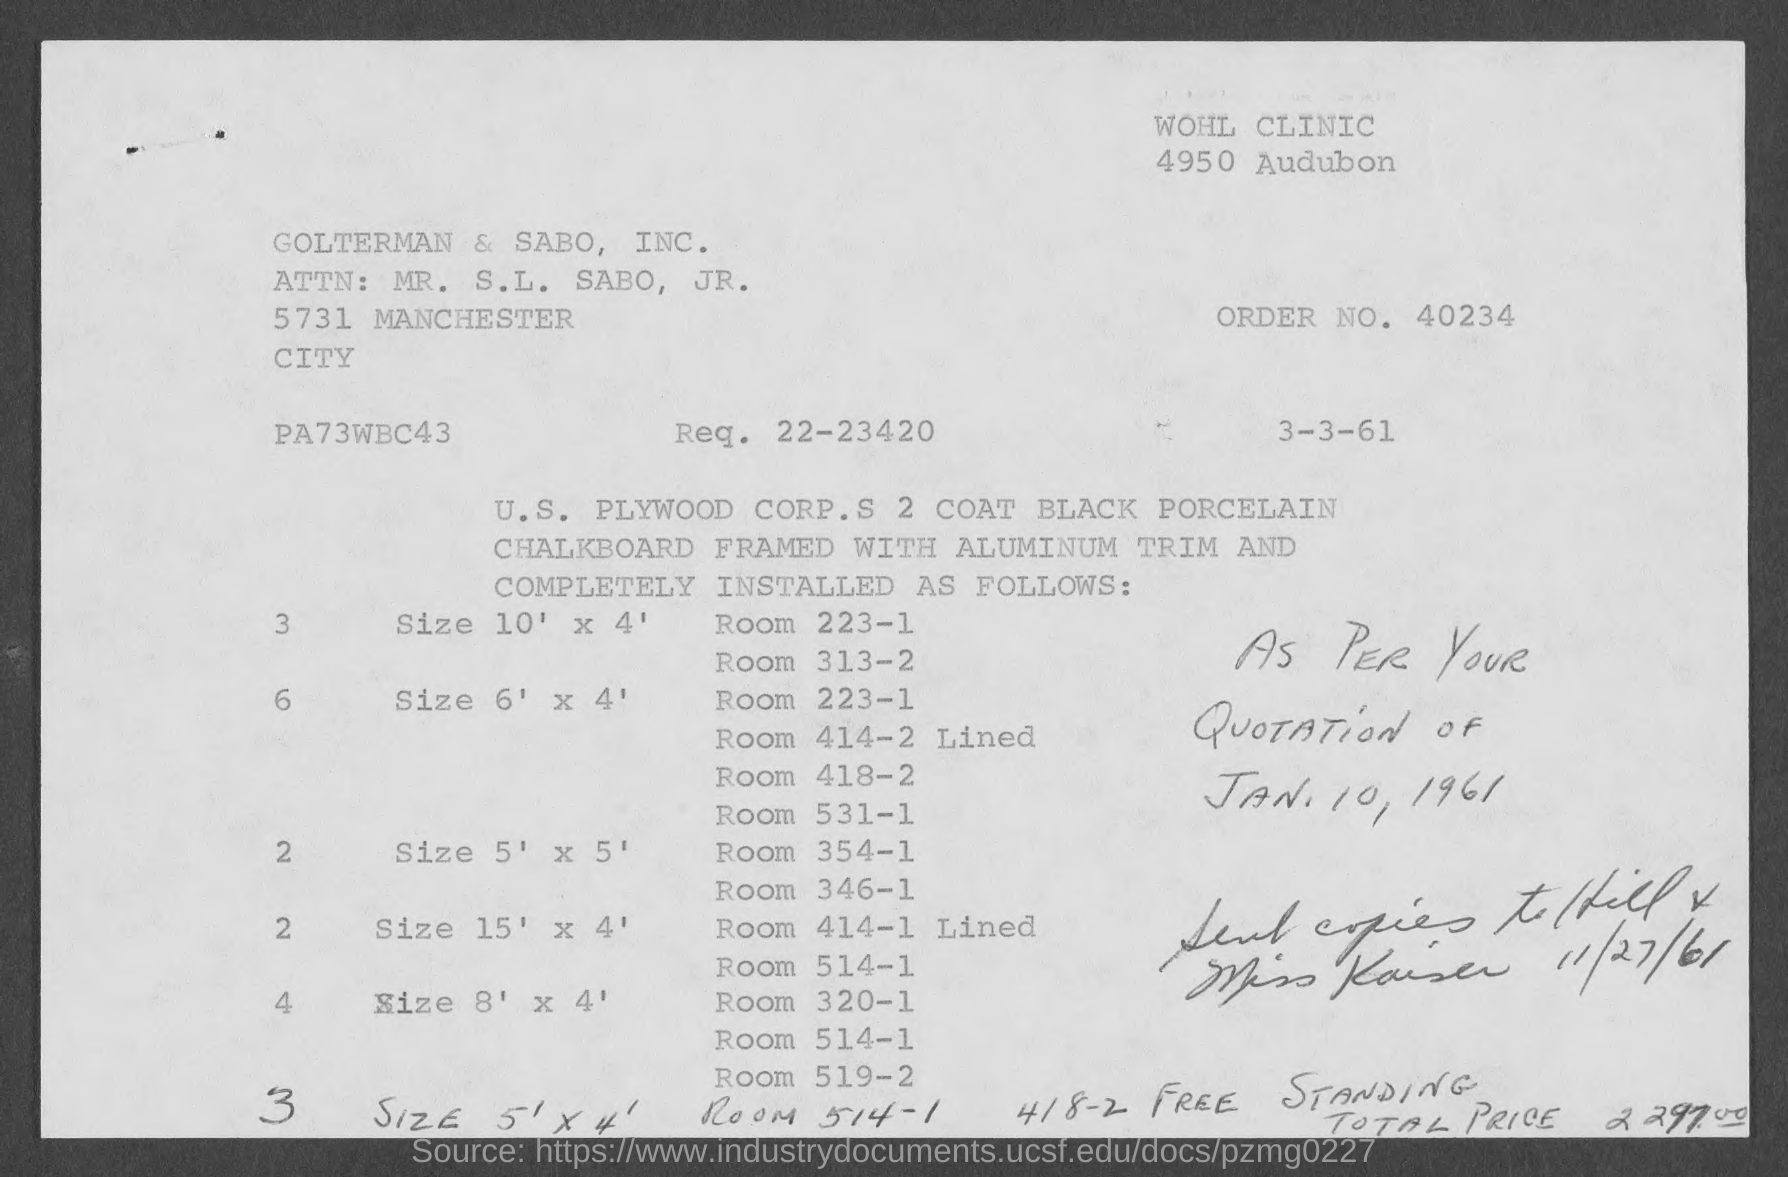Point out several critical features in this image. The request is for item 22-23420. The order number is 40234... 